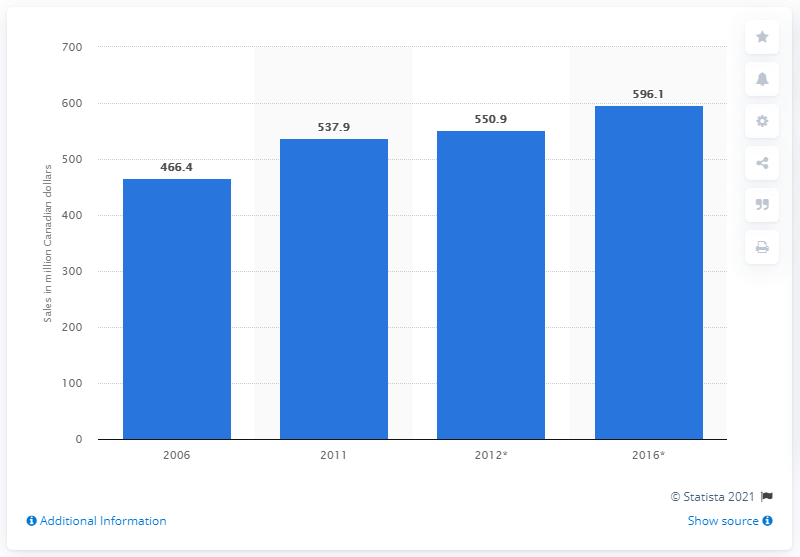Mention a couple of crucial points in this snapshot. Retail sales of savory biscuits and crackers in Canada from 2006 to 2016 were 466.4 million Canadian dollars. 